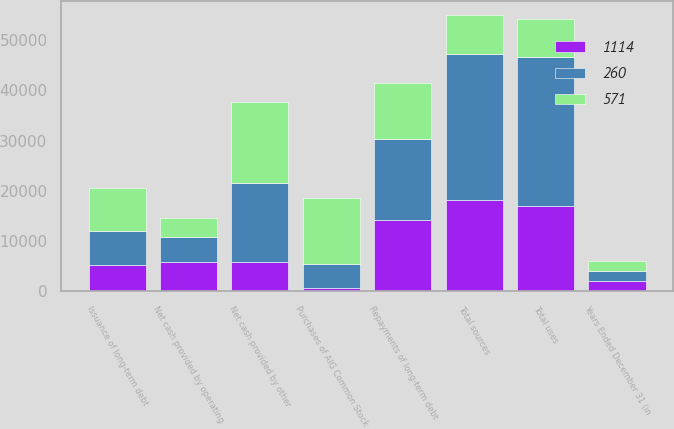Convert chart. <chart><loc_0><loc_0><loc_500><loc_500><stacked_bar_chart><ecel><fcel>Years Ended December 31 (in<fcel>Net cash provided by operating<fcel>Net cash provided by other<fcel>Issuance of long-term debt<fcel>Total sources<fcel>Repayments of long-term debt<fcel>Purchases of AIG Common Stock<fcel>Total uses<nl><fcel>260<fcel>2014<fcel>5007<fcel>15731<fcel>6687<fcel>29144<fcel>16160<fcel>4902<fcel>29641<nl><fcel>1114<fcel>2013<fcel>5865<fcel>5855<fcel>5235<fcel>18199<fcel>14197<fcel>597<fcel>16993<nl><fcel>571<fcel>2012<fcel>3676<fcel>16198<fcel>8612<fcel>7649.5<fcel>11101<fcel>13000<fcel>7649.5<nl></chart> 